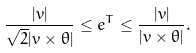Convert formula to latex. <formula><loc_0><loc_0><loc_500><loc_500>\frac { | v | } { \sqrt { 2 } | v \times \theta | } \leq e ^ { T } \leq \frac { | v | } { | v \times \theta | } .</formula> 